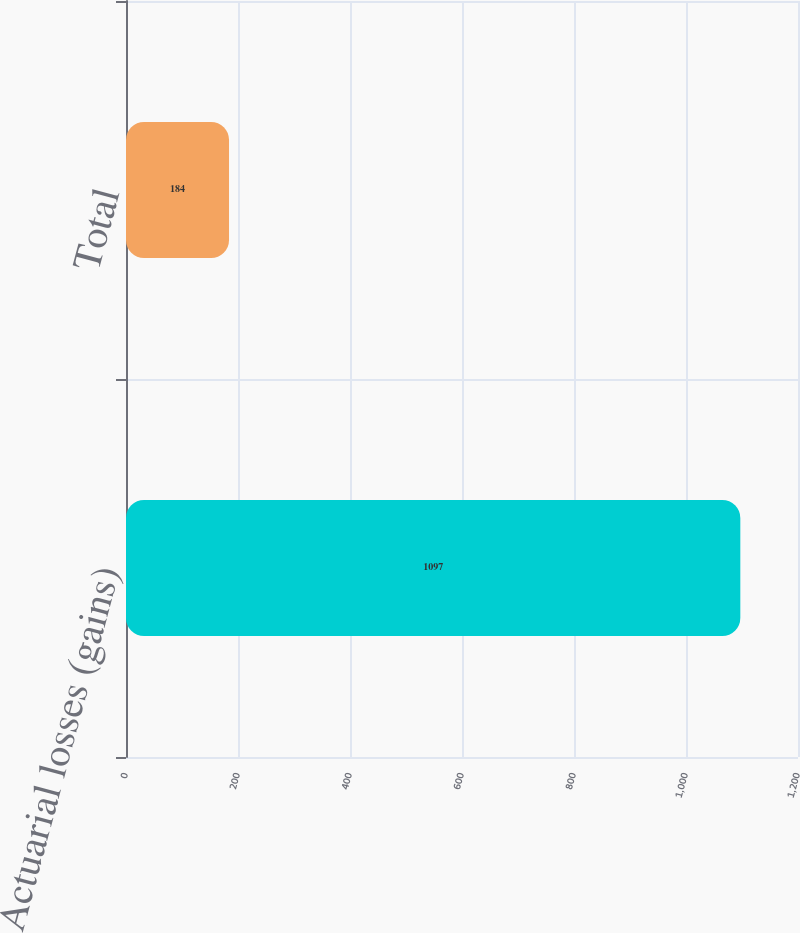Convert chart to OTSL. <chart><loc_0><loc_0><loc_500><loc_500><bar_chart><fcel>Actuarial losses (gains)<fcel>Total<nl><fcel>1097<fcel>184<nl></chart> 